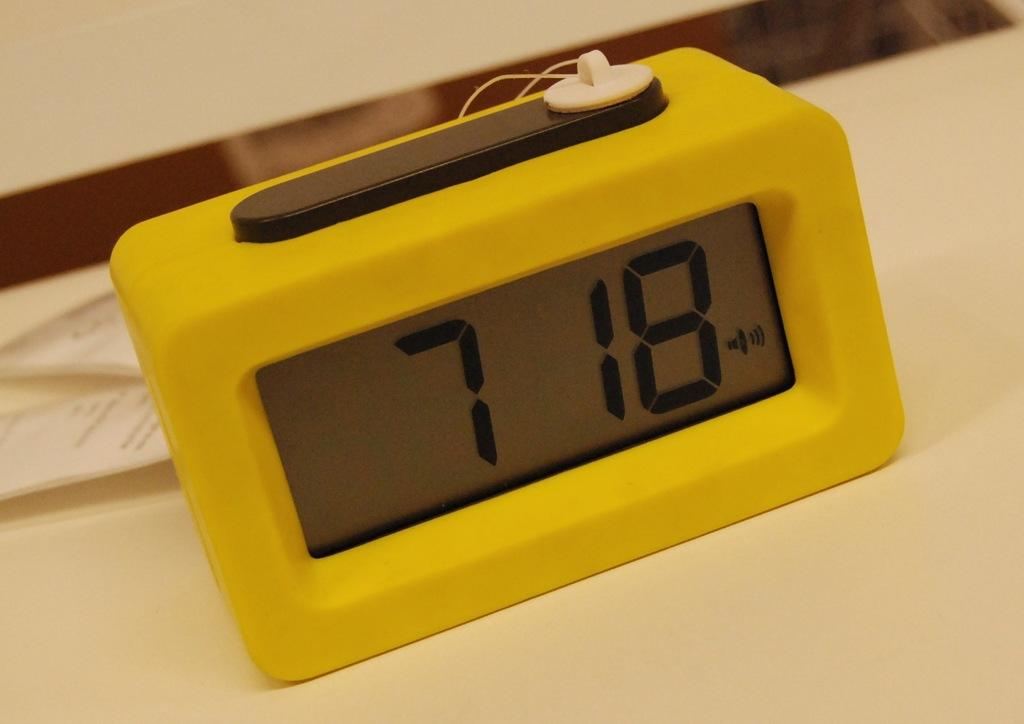<image>
Give a short and clear explanation of the subsequent image. a yellow digital alarm clock set at 7:18 on a white table 